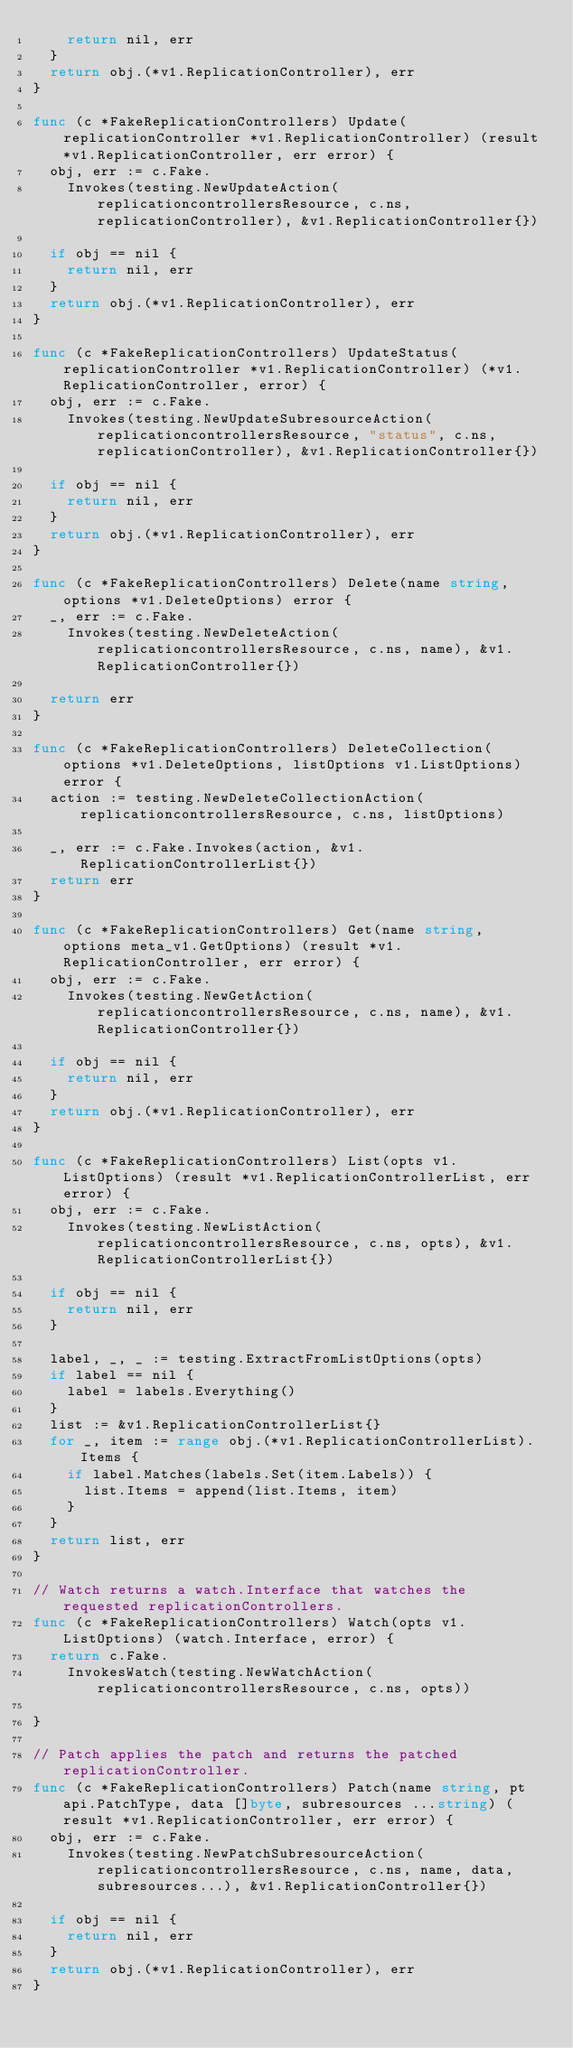Convert code to text. <code><loc_0><loc_0><loc_500><loc_500><_Go_>		return nil, err
	}
	return obj.(*v1.ReplicationController), err
}

func (c *FakeReplicationControllers) Update(replicationController *v1.ReplicationController) (result *v1.ReplicationController, err error) {
	obj, err := c.Fake.
		Invokes(testing.NewUpdateAction(replicationcontrollersResource, c.ns, replicationController), &v1.ReplicationController{})

	if obj == nil {
		return nil, err
	}
	return obj.(*v1.ReplicationController), err
}

func (c *FakeReplicationControllers) UpdateStatus(replicationController *v1.ReplicationController) (*v1.ReplicationController, error) {
	obj, err := c.Fake.
		Invokes(testing.NewUpdateSubresourceAction(replicationcontrollersResource, "status", c.ns, replicationController), &v1.ReplicationController{})

	if obj == nil {
		return nil, err
	}
	return obj.(*v1.ReplicationController), err
}

func (c *FakeReplicationControllers) Delete(name string, options *v1.DeleteOptions) error {
	_, err := c.Fake.
		Invokes(testing.NewDeleteAction(replicationcontrollersResource, c.ns, name), &v1.ReplicationController{})

	return err
}

func (c *FakeReplicationControllers) DeleteCollection(options *v1.DeleteOptions, listOptions v1.ListOptions) error {
	action := testing.NewDeleteCollectionAction(replicationcontrollersResource, c.ns, listOptions)

	_, err := c.Fake.Invokes(action, &v1.ReplicationControllerList{})
	return err
}

func (c *FakeReplicationControllers) Get(name string, options meta_v1.GetOptions) (result *v1.ReplicationController, err error) {
	obj, err := c.Fake.
		Invokes(testing.NewGetAction(replicationcontrollersResource, c.ns, name), &v1.ReplicationController{})

	if obj == nil {
		return nil, err
	}
	return obj.(*v1.ReplicationController), err
}

func (c *FakeReplicationControllers) List(opts v1.ListOptions) (result *v1.ReplicationControllerList, err error) {
	obj, err := c.Fake.
		Invokes(testing.NewListAction(replicationcontrollersResource, c.ns, opts), &v1.ReplicationControllerList{})

	if obj == nil {
		return nil, err
	}

	label, _, _ := testing.ExtractFromListOptions(opts)
	if label == nil {
		label = labels.Everything()
	}
	list := &v1.ReplicationControllerList{}
	for _, item := range obj.(*v1.ReplicationControllerList).Items {
		if label.Matches(labels.Set(item.Labels)) {
			list.Items = append(list.Items, item)
		}
	}
	return list, err
}

// Watch returns a watch.Interface that watches the requested replicationControllers.
func (c *FakeReplicationControllers) Watch(opts v1.ListOptions) (watch.Interface, error) {
	return c.Fake.
		InvokesWatch(testing.NewWatchAction(replicationcontrollersResource, c.ns, opts))

}

// Patch applies the patch and returns the patched replicationController.
func (c *FakeReplicationControllers) Patch(name string, pt api.PatchType, data []byte, subresources ...string) (result *v1.ReplicationController, err error) {
	obj, err := c.Fake.
		Invokes(testing.NewPatchSubresourceAction(replicationcontrollersResource, c.ns, name, data, subresources...), &v1.ReplicationController{})

	if obj == nil {
		return nil, err
	}
	return obj.(*v1.ReplicationController), err
}
</code> 